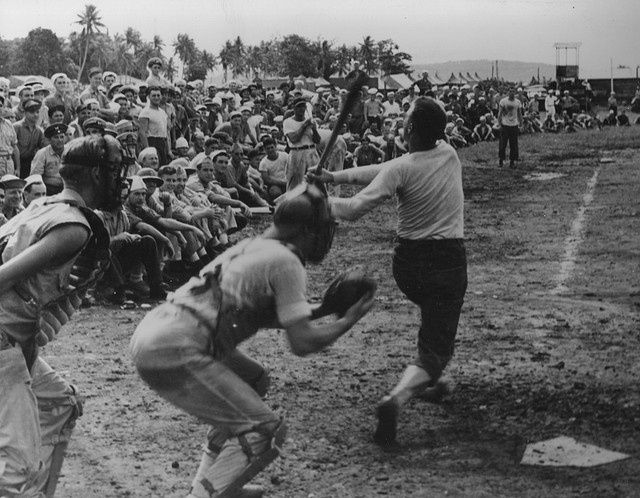Describe the objects in this image and their specific colors. I can see people in lightgray, black, gray, and darkgray tones, people in lightgray, gray, black, darkgray, and silver tones, people in lightgray, gray, black, and darkgray tones, people in gray, black, darkgray, and lightgray tones, and people in gray, black, darkgray, and lightgray tones in this image. 